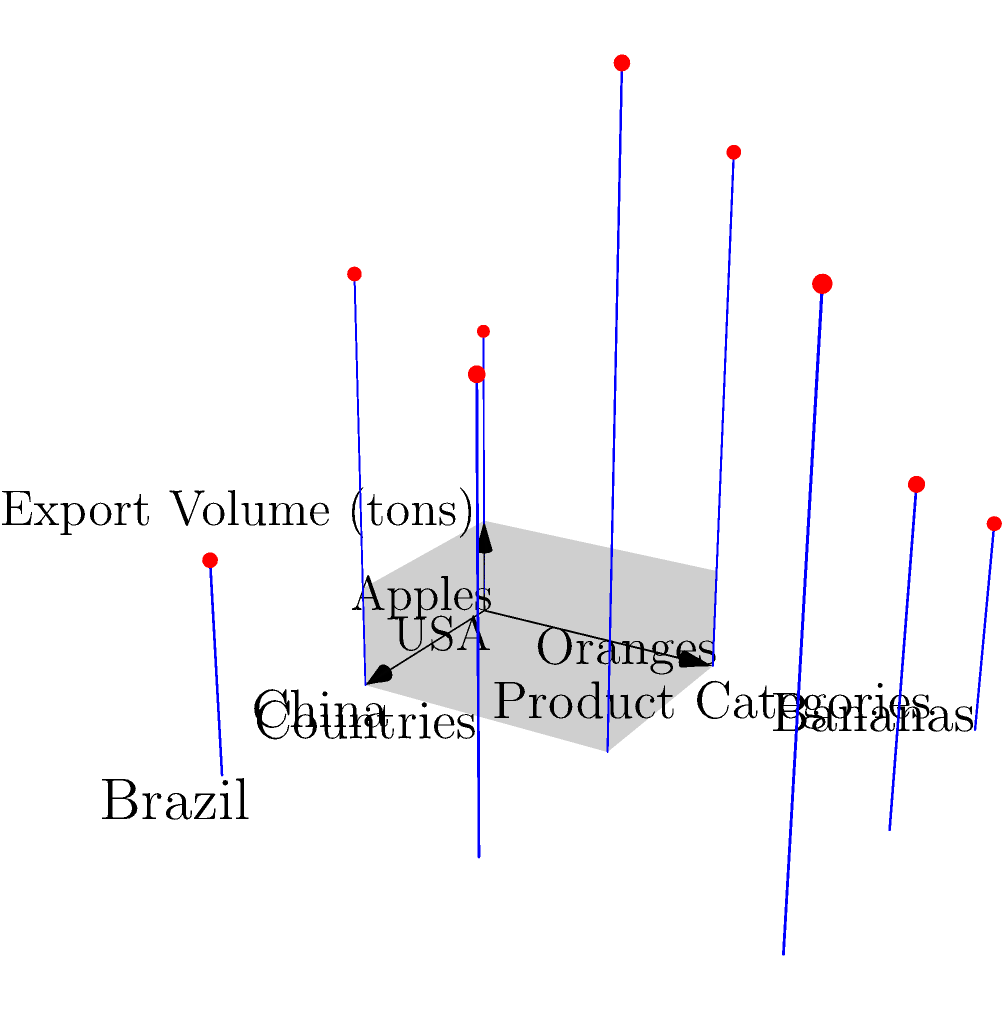Based on the 3D coordinate system shown, which country has the highest total export volume across all product categories, and what is this total volume? To solve this question, we need to follow these steps:

1. Identify the countries and product categories:
   - Countries (x-axis): USA (0), China (1), Brazil (2)
   - Product categories (y-axis): Apples (0), Oranges (1), Bananas (2)

2. Sum up the export volumes for each country:

   For USA:
   - Apples: 3 tons
   - Oranges: 5 tons
   - Bananas: 2 tons
   Total for USA: $3 + 5 + 2 = 10$ tons

   For China:
   - Apples: 4 tons
   - Oranges: 6 tons
   - Bananas: 3 tons
   Total for China: $4 + 6 + 3 = 13$ tons

   For Brazil:
   - Apples: 2 tons
   - Oranges: 4 tons
   - Bananas: 5 tons
   Total for Brazil: $2 + 4 + 5 = 11$ tons

3. Compare the totals:
   USA: 10 tons
   China: 13 tons
   Brazil: 11 tons

4. Identify the highest total:
   China has the highest total export volume with 13 tons.
Answer: China, 13 tons 